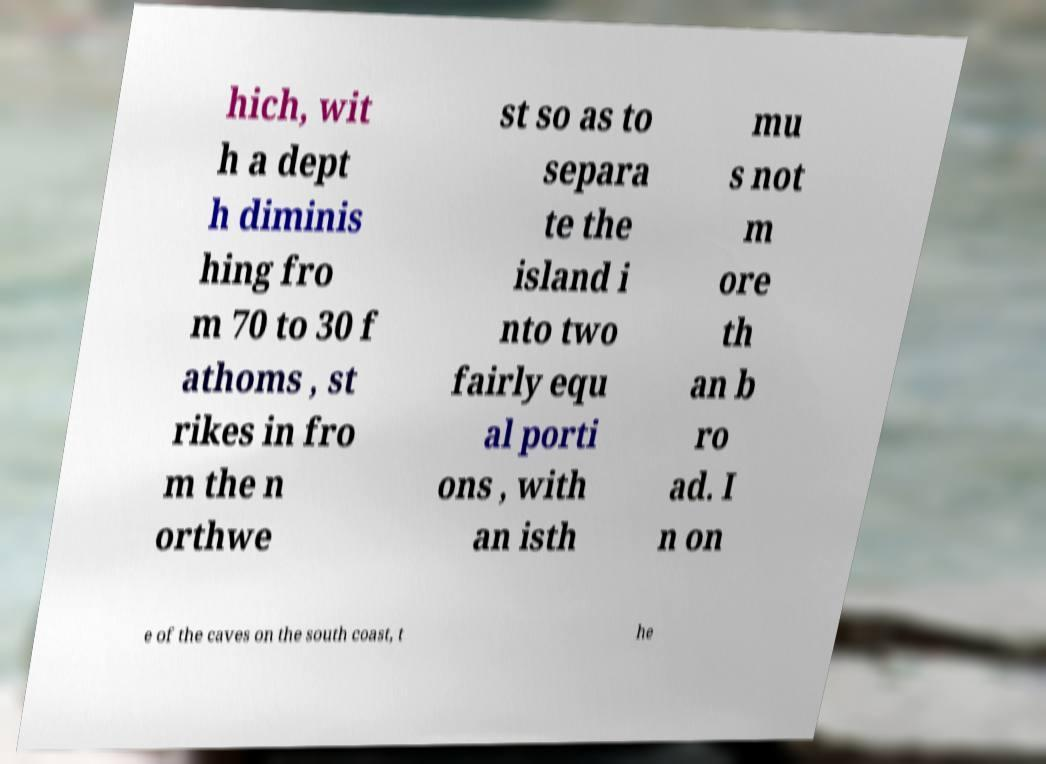What messages or text are displayed in this image? I need them in a readable, typed format. hich, wit h a dept h diminis hing fro m 70 to 30 f athoms , st rikes in fro m the n orthwe st so as to separa te the island i nto two fairly equ al porti ons , with an isth mu s not m ore th an b ro ad. I n on e of the caves on the south coast, t he 